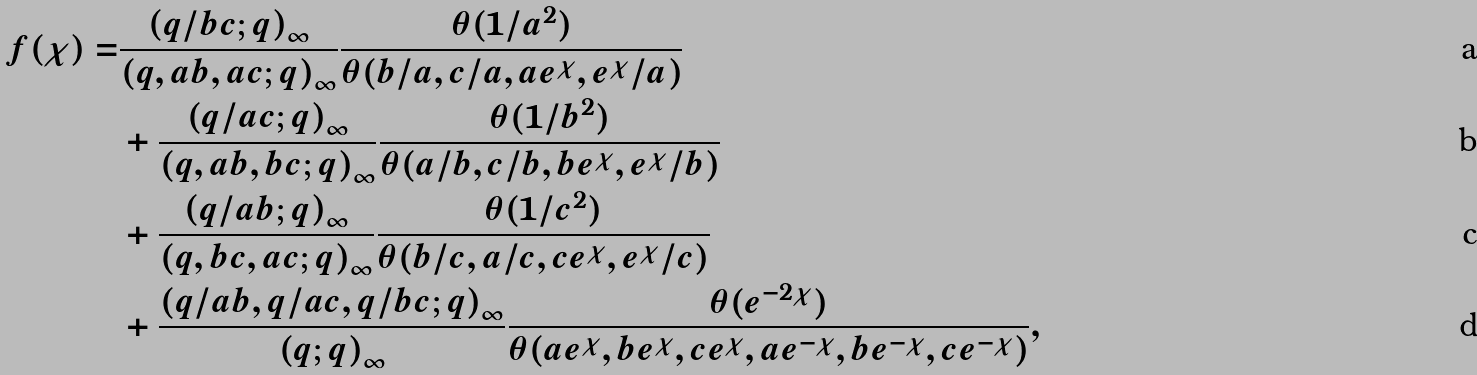<formula> <loc_0><loc_0><loc_500><loc_500>f ( \chi ) = & \frac { \left ( q / b c ; q \right ) _ { \infty } } { \left ( q , a b , a c ; q \right ) _ { \infty } } \frac { \theta ( 1 / a ^ { 2 } ) } { \theta ( b / a , c / a , a e ^ { \chi } , e ^ { \chi } / a ) } \\ & + \frac { \left ( q / a c ; q \right ) _ { \infty } } { \left ( q , a b , b c ; q \right ) _ { \infty } } \frac { \theta ( 1 / b ^ { 2 } ) } { \theta ( a / b , c / b , b e ^ { \chi } , e ^ { \chi } / b ) } \\ & + \frac { \left ( q / a b ; q \right ) _ { \infty } } { \left ( q , b c , a c ; q \right ) _ { \infty } } \frac { \theta ( 1 / c ^ { 2 } ) } { \theta ( b / c , a / c , c e ^ { \chi } , e ^ { \chi } / c ) } \\ & + \frac { \left ( q / a b , q / a c , q / b c ; q \right ) _ { \infty } } { \left ( q ; q \right ) _ { \infty } } \frac { \theta ( e ^ { - 2 \chi } ) } { \theta ( a e ^ { \chi } , b e ^ { \chi } , c e ^ { \chi } , a e ^ { - \chi } , b e ^ { - \chi } , c e ^ { - \chi } ) } ,</formula> 